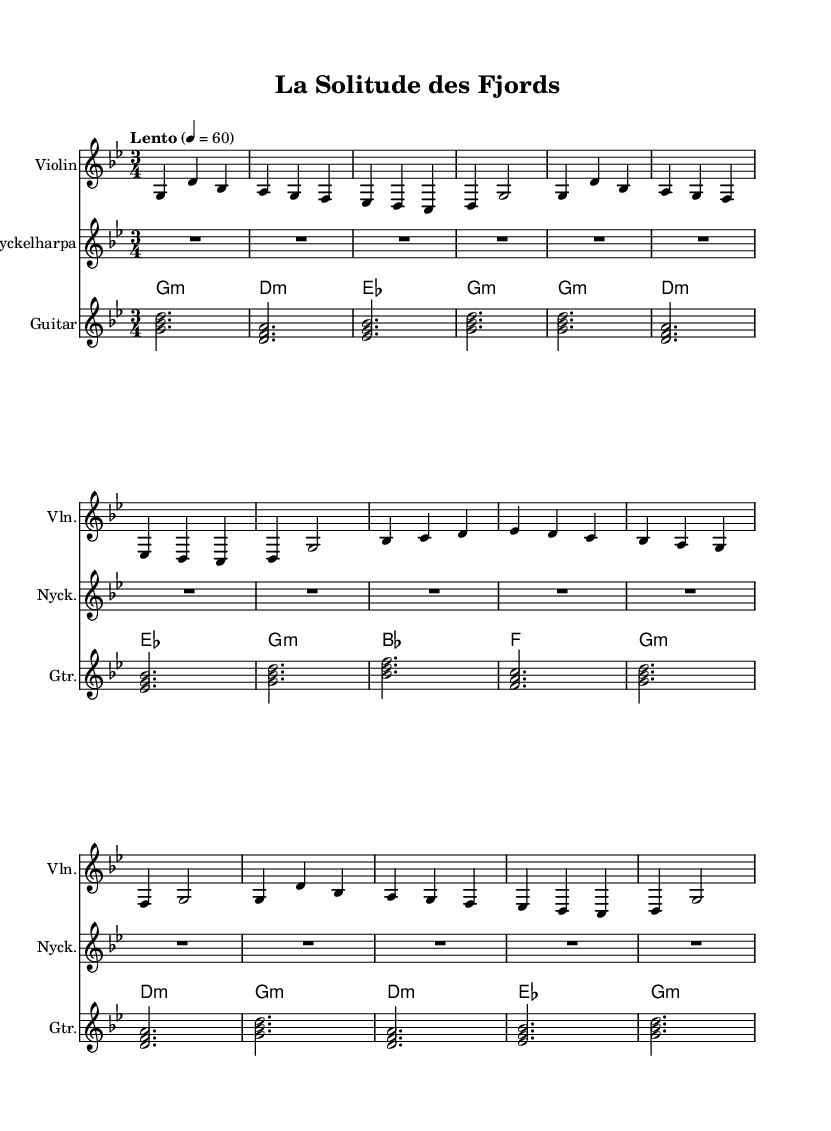What is the key signature of this music? The key signature indicates the tonal center of the piece. In the staff, you can observe a single flat, which corresponds to the key of G minor.
Answer: G minor What is the time signature of this piece? The time signature is located at the beginning of the staff and indicates the number of beats in a measure. Here, the time signature is 3/4, meaning there are three beats in each measure, with each quarter note receiving one beat.
Answer: 3/4 What is the tempo marking for the piece? The tempo marking appears above the staff, providing information about the speed of the piece. In this case, it is indicated as "Lento," which typically means a slow tempo, with a metronome marking of 60 beats per minute.
Answer: Lento How many measures are in the violin part? To determine the number of measures, you can count the number of vertical bar lines indicated in the violin part. There are 8 measures in total, as evidenced by 8 separate groupings of notes separated by bar lines.
Answer: 8 What is the first note played by the nyckelharpa? The nyckelharpa part indicates a rest for a duration of 12 beats, meaning no notes are played initially. Since it starts with a rest and does not show any notes, the first note is absent.
Answer: None What are the chords used in the guitar part? The chords are shown above the stave in chord symbols. By analyzing the guitar music, the following chords are identified: G minor, D minor, E flat, and G minor.
Answer: G minor, D minor, E flat 